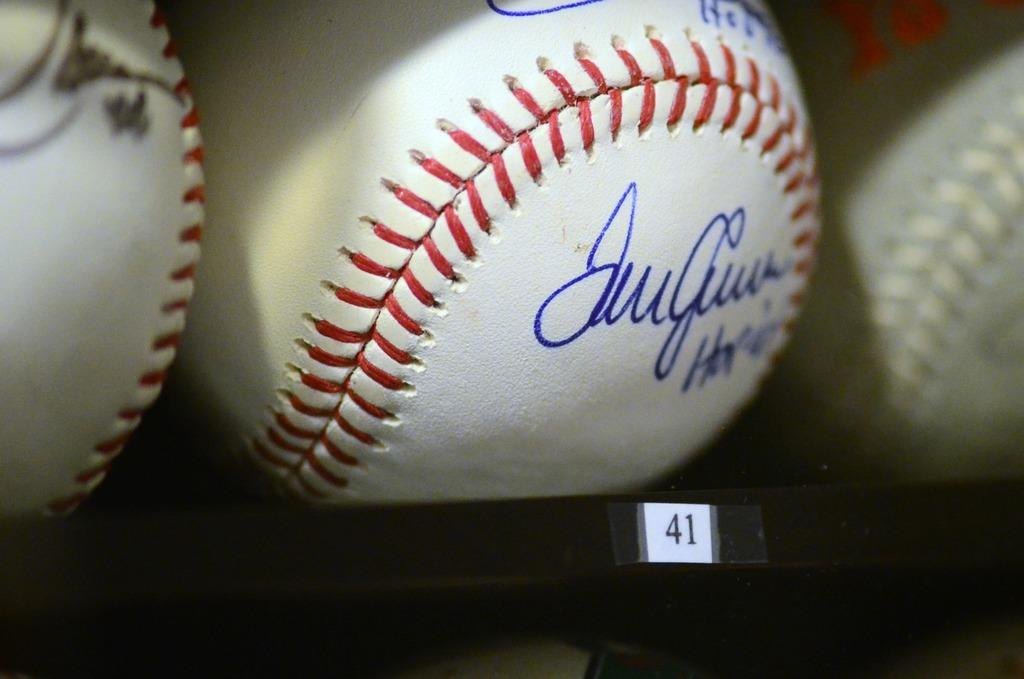<image>
Give a short and clear explanation of the subsequent image. An autographed baseball sits above a label reading 41. 